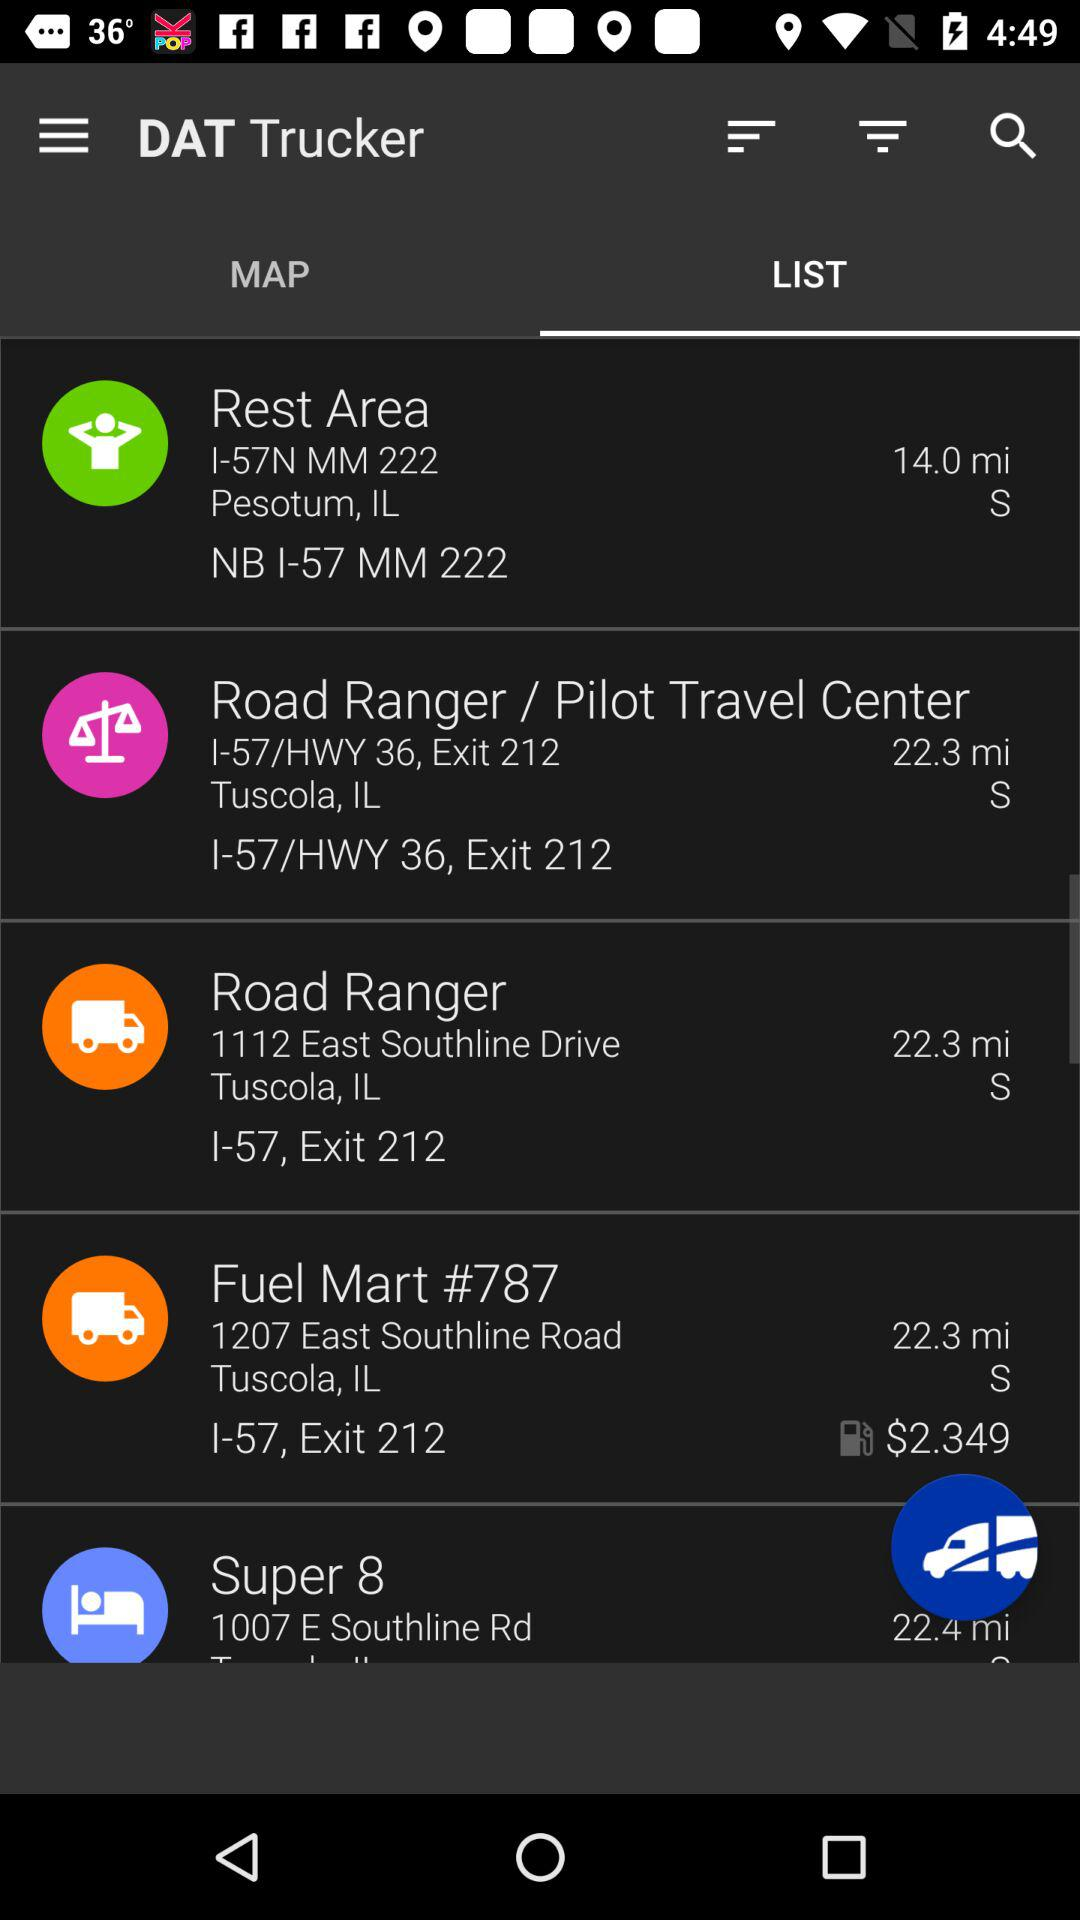What location is 14.0 miles away? The location that is 14.0 miles away is I-57N MM 222, Pesotum, IL, NB I-57 MM 222. 